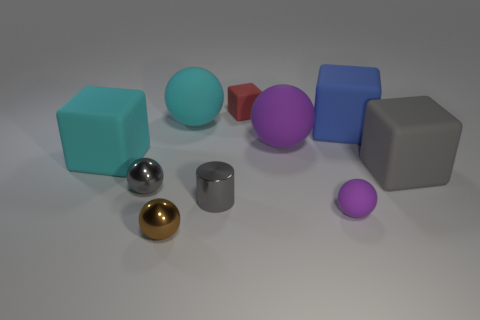How many big purple rubber balls are behind the blue block?
Make the answer very short. 0. What color is the tiny object behind the cyan rubber cube on the left side of the tiny thing to the left of the small brown sphere?
Provide a short and direct response. Red. Do the small shiny sphere that is in front of the small purple sphere and the rubber ball that is in front of the cyan cube have the same color?
Keep it short and to the point. No. The gray object on the right side of the purple ball behind the large gray matte cube is what shape?
Keep it short and to the point. Cube. Is there a purple thing of the same size as the brown metallic ball?
Provide a succinct answer. Yes. How many small shiny things have the same shape as the large purple object?
Your answer should be compact. 2. Are there the same number of brown metallic things to the right of the small red thing and cyan spheres that are in front of the tiny purple thing?
Provide a short and direct response. Yes. Is there a tiny red rubber object?
Provide a short and direct response. Yes. What size is the cylinder that is in front of the big blue matte object that is to the right of the large matte ball that is in front of the cyan rubber sphere?
Give a very brief answer. Small. What is the shape of the red rubber thing that is the same size as the brown metal ball?
Your answer should be compact. Cube. 